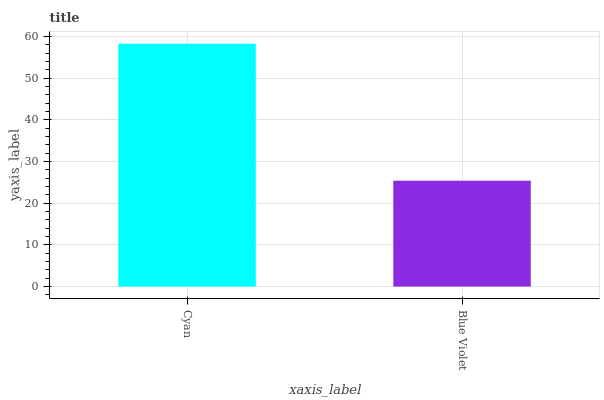Is Blue Violet the minimum?
Answer yes or no. Yes. Is Cyan the maximum?
Answer yes or no. Yes. Is Blue Violet the maximum?
Answer yes or no. No. Is Cyan greater than Blue Violet?
Answer yes or no. Yes. Is Blue Violet less than Cyan?
Answer yes or no. Yes. Is Blue Violet greater than Cyan?
Answer yes or no. No. Is Cyan less than Blue Violet?
Answer yes or no. No. Is Cyan the high median?
Answer yes or no. Yes. Is Blue Violet the low median?
Answer yes or no. Yes. Is Blue Violet the high median?
Answer yes or no. No. Is Cyan the low median?
Answer yes or no. No. 